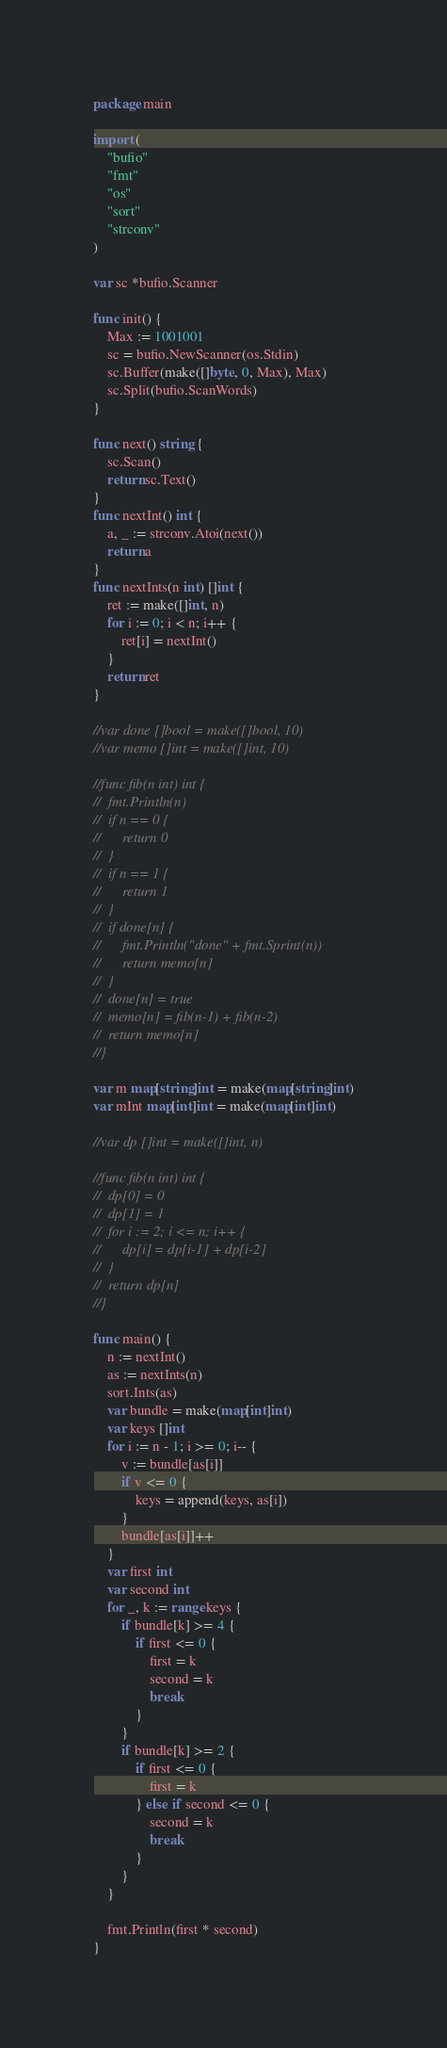<code> <loc_0><loc_0><loc_500><loc_500><_Go_>package main

import (
	"bufio"
	"fmt"
	"os"
	"sort"
	"strconv"
)

var sc *bufio.Scanner

func init() {
	Max := 1001001
	sc = bufio.NewScanner(os.Stdin)
	sc.Buffer(make([]byte, 0, Max), Max)
	sc.Split(bufio.ScanWords)
}

func next() string {
	sc.Scan()
	return sc.Text()
}
func nextInt() int {
	a, _ := strconv.Atoi(next())
	return a
}
func nextInts(n int) []int {
	ret := make([]int, n)
	for i := 0; i < n; i++ {
		ret[i] = nextInt()
	}
	return ret
}

//var done []bool = make([]bool, 10)
//var memo []int = make([]int, 10)

//func fib(n int) int {
//	fmt.Println(n)
//	if n == 0 {
//		return 0
//	}
//	if n == 1 {
//		return 1
//	}
//	if done[n] {
//		fmt.Println("done" + fmt.Sprint(n))
//		return memo[n]
//	}
//	done[n] = true
//	memo[n] = fib(n-1) + fib(n-2)
//	return memo[n]
//}

var m map[string]int = make(map[string]int)
var mInt map[int]int = make(map[int]int)

//var dp []int = make([]int, n)

//func fib(n int) int {
//	dp[0] = 0
//	dp[1] = 1
//	for i := 2; i <= n; i++ {
//		dp[i] = dp[i-1] + dp[i-2]
//	}
//	return dp[n]
//}

func main() {
	n := nextInt()
	as := nextInts(n)
	sort.Ints(as)
	var bundle = make(map[int]int)
	var keys []int
	for i := n - 1; i >= 0; i-- {
		v := bundle[as[i]]
		if v <= 0 {
			keys = append(keys, as[i])
		}
		bundle[as[i]]++
	}
	var first int
	var second int
	for _, k := range keys {
		if bundle[k] >= 4 {
			if first <= 0 {
				first = k
				second = k
				break
			}
		}
		if bundle[k] >= 2 {
			if first <= 0 {
				first = k
			} else if second <= 0 {
				second = k
				break
			}
		}
	}

	fmt.Println(first * second)
}
</code> 